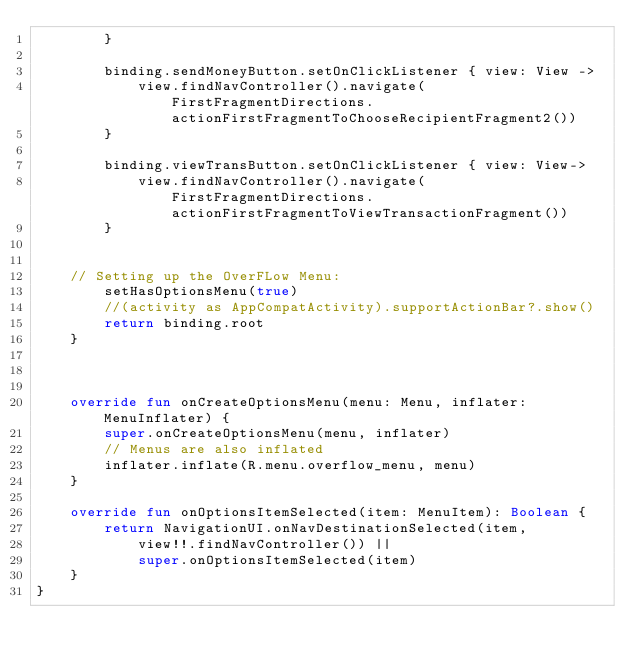<code> <loc_0><loc_0><loc_500><loc_500><_Kotlin_>        }

        binding.sendMoneyButton.setOnClickListener { view: View ->
            view.findNavController().navigate(FirstFragmentDirections.actionFirstFragmentToChooseRecipientFragment2())
        }

        binding.viewTransButton.setOnClickListener { view: View->
            view.findNavController().navigate(FirstFragmentDirections.actionFirstFragmentToViewTransactionFragment())
        }


    // Setting up the OverFLow Menu:
        setHasOptionsMenu(true)
        //(activity as AppCompatActivity).supportActionBar?.show()
        return binding.root
    }



    override fun onCreateOptionsMenu(menu: Menu, inflater: MenuInflater) {
        super.onCreateOptionsMenu(menu, inflater)
        // Menus are also inflated
        inflater.inflate(R.menu.overflow_menu, menu)
    }

    override fun onOptionsItemSelected(item: MenuItem): Boolean {
        return NavigationUI.onNavDestinationSelected(item,
            view!!.findNavController()) ||
            super.onOptionsItemSelected(item)
    }
}
</code> 